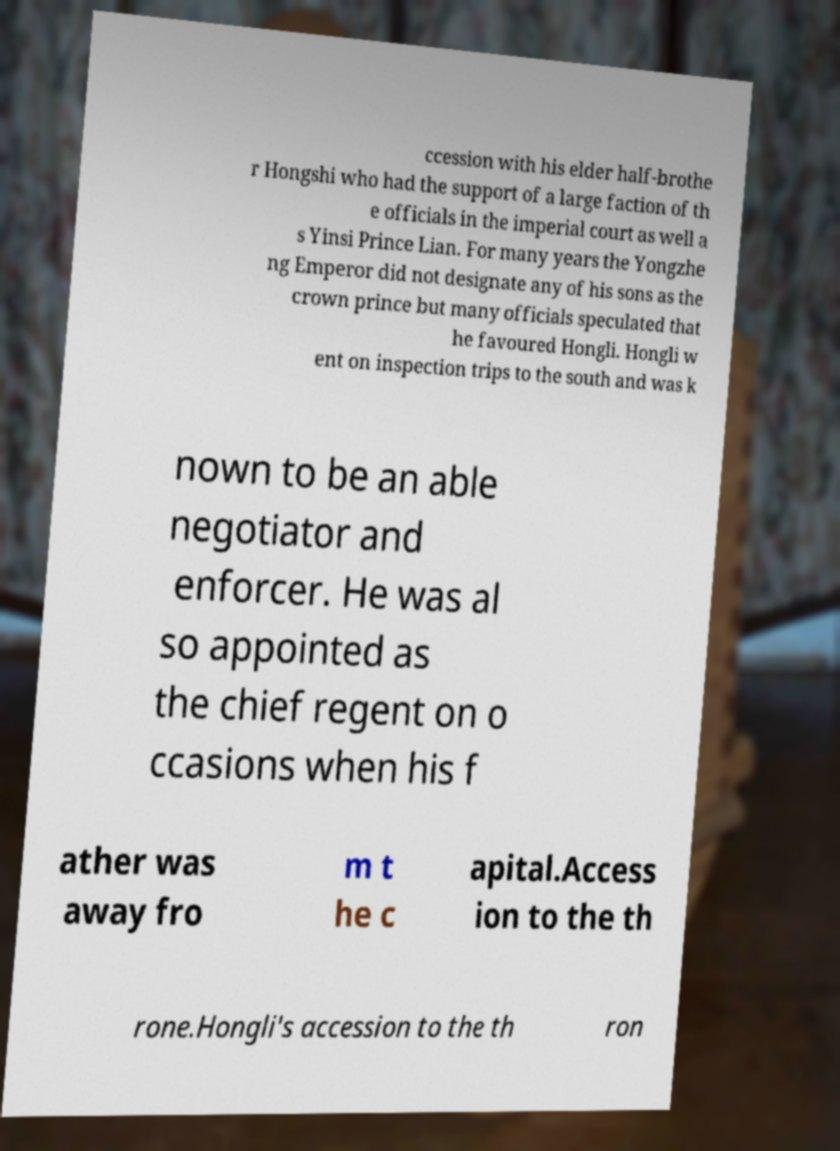Please identify and transcribe the text found in this image. ccession with his elder half-brothe r Hongshi who had the support of a large faction of th e officials in the imperial court as well a s Yinsi Prince Lian. For many years the Yongzhe ng Emperor did not designate any of his sons as the crown prince but many officials speculated that he favoured Hongli. Hongli w ent on inspection trips to the south and was k nown to be an able negotiator and enforcer. He was al so appointed as the chief regent on o ccasions when his f ather was away fro m t he c apital.Access ion to the th rone.Hongli's accession to the th ron 